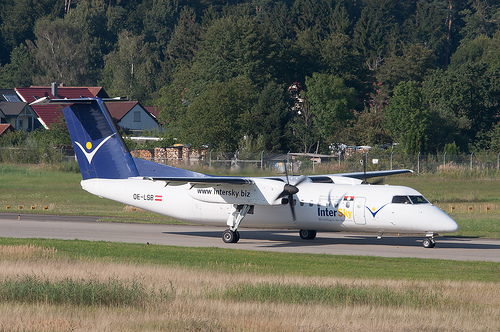Please provide a short description for this region: [0.65, 0.27, 0.73, 0.36]. The region identified by [0.65, 0.27, 0.73, 0.36] includes 'Green leaves in brown trees,' likely highlighting a natural backdrop behind the foreground elements. 